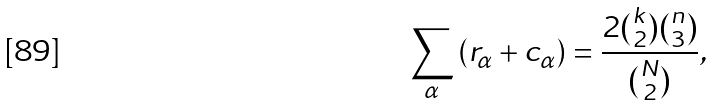Convert formula to latex. <formula><loc_0><loc_0><loc_500><loc_500>\sum _ { \alpha } \left ( r _ { \alpha } + c _ { \alpha } \right ) = \frac { 2 \binom { k } { 2 } \binom { n } { 3 } } { \binom { N } { 2 } } ,</formula> 